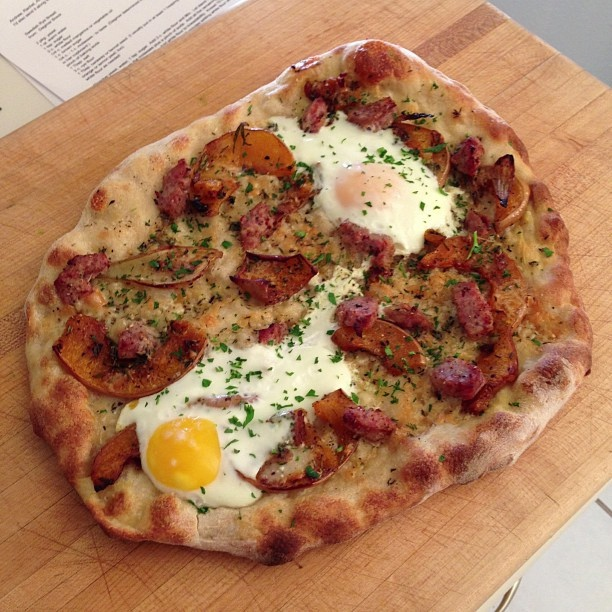Describe the objects in this image and their specific colors. I can see pizza in lightgray, maroon, brown, gray, and tan tones and book in lightgray, tan, and darkgray tones in this image. 